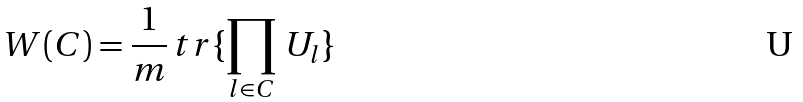<formula> <loc_0><loc_0><loc_500><loc_500>W ( C ) = \frac { 1 } { m } \, t r \{ \prod _ { l \in C } \, U _ { l } \}</formula> 